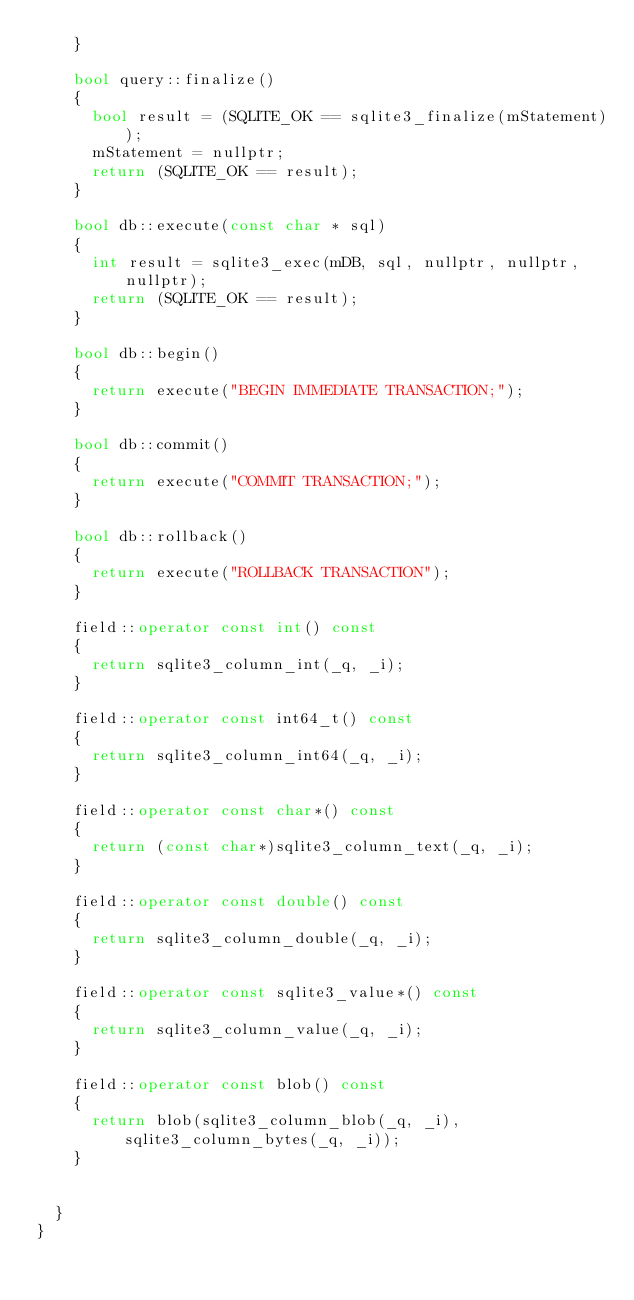<code> <loc_0><loc_0><loc_500><loc_500><_C++_>    }

    bool query::finalize()
    {
      bool result = (SQLITE_OK == sqlite3_finalize(mStatement));
      mStatement = nullptr;
      return (SQLITE_OK == result);
    }

    bool db::execute(const char * sql)
    {
      int result = sqlite3_exec(mDB, sql, nullptr, nullptr, nullptr);
      return (SQLITE_OK == result);
    }

    bool db::begin()
    {
      return execute("BEGIN IMMEDIATE TRANSACTION;");
    }

    bool db::commit()
    {
      return execute("COMMIT TRANSACTION;");
    }

    bool db::rollback()
    {
      return execute("ROLLBACK TRANSACTION");
    }

    field::operator const int() const
    {
      return sqlite3_column_int(_q, _i);
    }

    field::operator const int64_t() const
    {
      return sqlite3_column_int64(_q, _i);
    }

    field::operator const char*() const
    {
      return (const char*)sqlite3_column_text(_q, _i);
    }

    field::operator const double() const
    {
      return sqlite3_column_double(_q, _i);
    }

    field::operator const sqlite3_value*() const
    {
      return sqlite3_column_value(_q, _i);
    }

    field::operator const blob() const
    {
      return blob(sqlite3_column_blob(_q, _i), sqlite3_column_bytes(_q, _i));
    }


  }
}</code> 